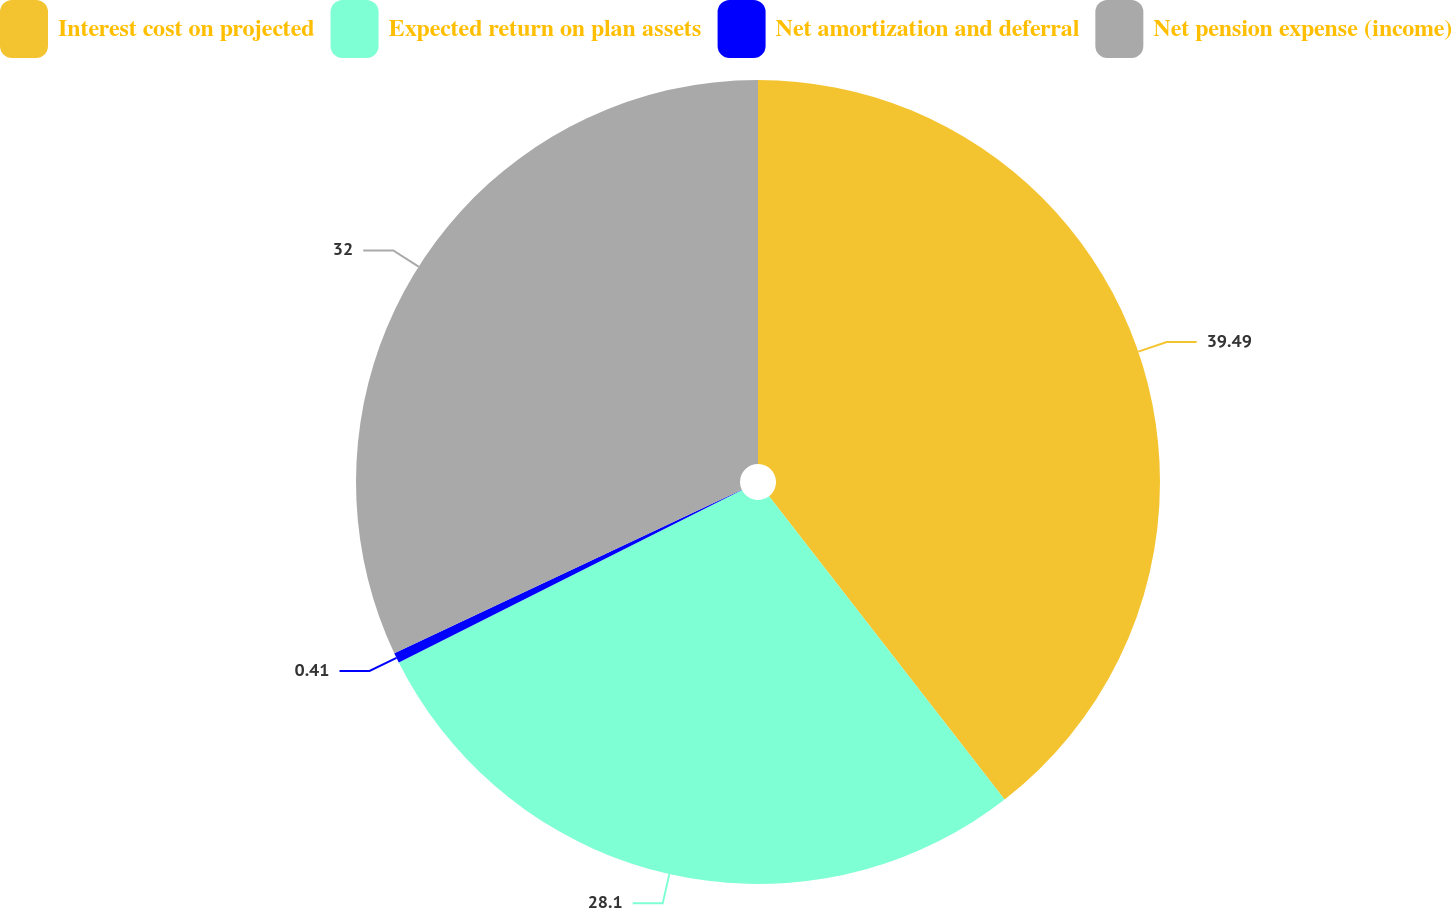Convert chart to OTSL. <chart><loc_0><loc_0><loc_500><loc_500><pie_chart><fcel>Interest cost on projected<fcel>Expected return on plan assets<fcel>Net amortization and deferral<fcel>Net pension expense (income)<nl><fcel>39.49%<fcel>28.1%<fcel>0.41%<fcel>32.0%<nl></chart> 